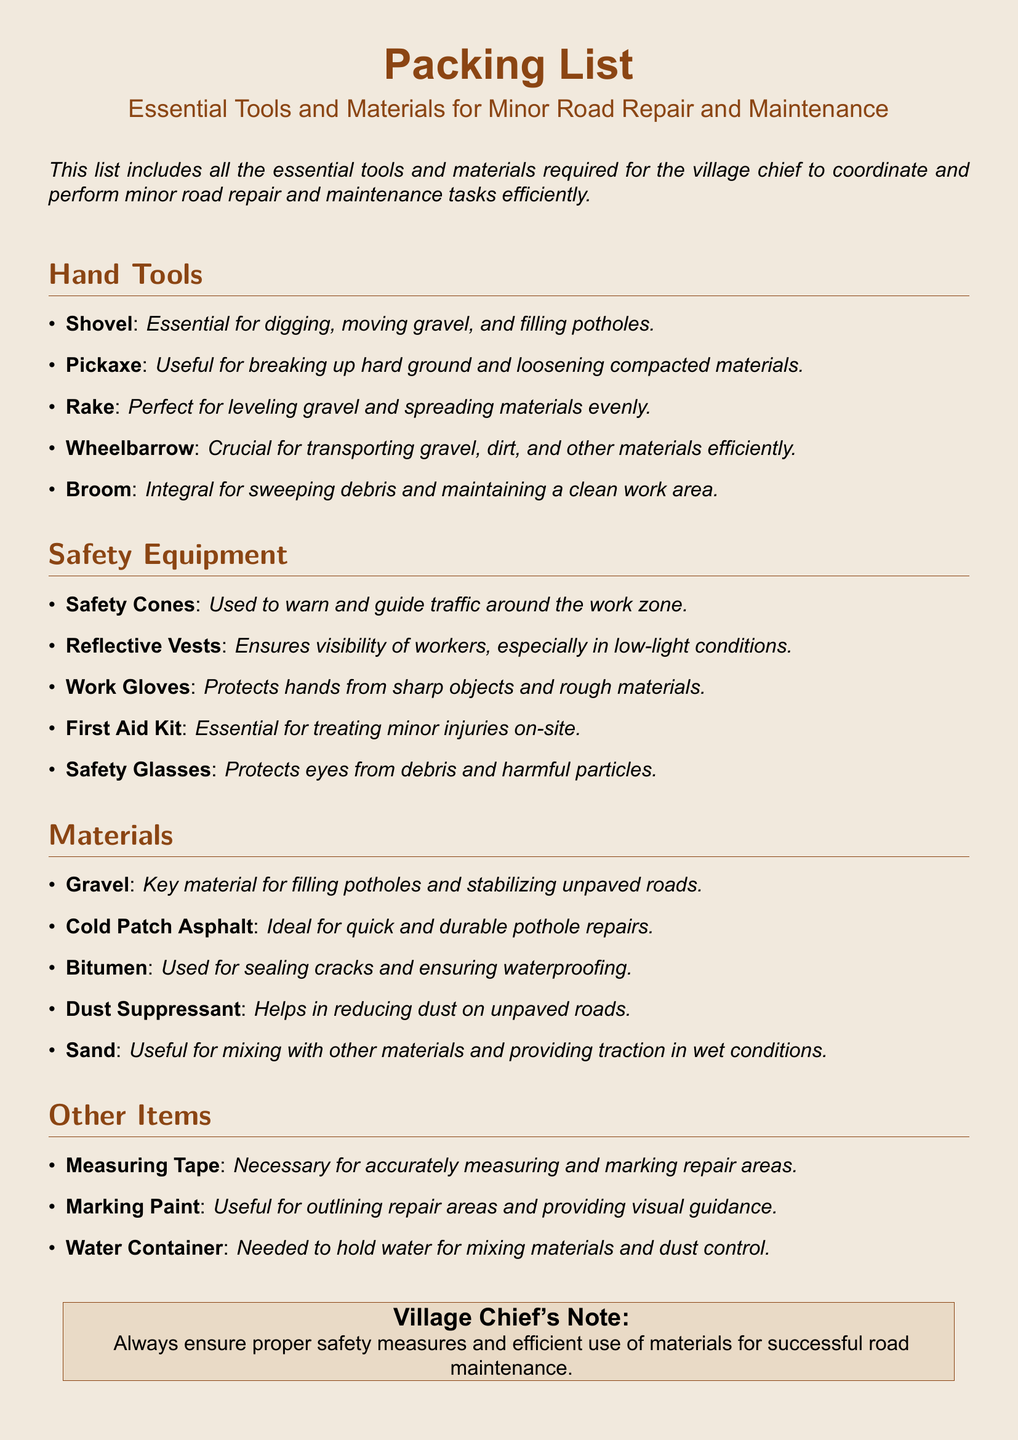What is the main purpose of the document? The document serves as a packing list outlining essential tools and materials needed for minor road repair and maintenance tasks.
Answer: Packing list How many types of hand tools are listed? The document specifically lists five different hand tools under the hand tools section.
Answer: Five What should you use to fill potholes? The document mentions gravel as a key material for filling potholes.
Answer: Gravel What item is essential for ensuring the visibility of workers? Reflective vests are listed in the safety equipment section as essential for workers' visibility.
Answer: Reflective Vests What is one item included in the safety equipment? Safety glasses are mentioned in the safety equipment section.
Answer: Safety Glasses What is required for mixing materials and dust control? A water container is specified in the other items section for this purpose.
Answer: Water Container How many materials are listed in total? The materials section details five different materials required for road repair.
Answer: Five What tool is necessary for accurately measuring repair areas? The document lists measuring tape as the tool necessary for this task.
Answer: Measuring Tape What kind of asphalt is described for quick repairs? Cold patch asphalt is emphasized in the materials section for its quick repair capabilities.
Answer: Cold Patch Asphalt 